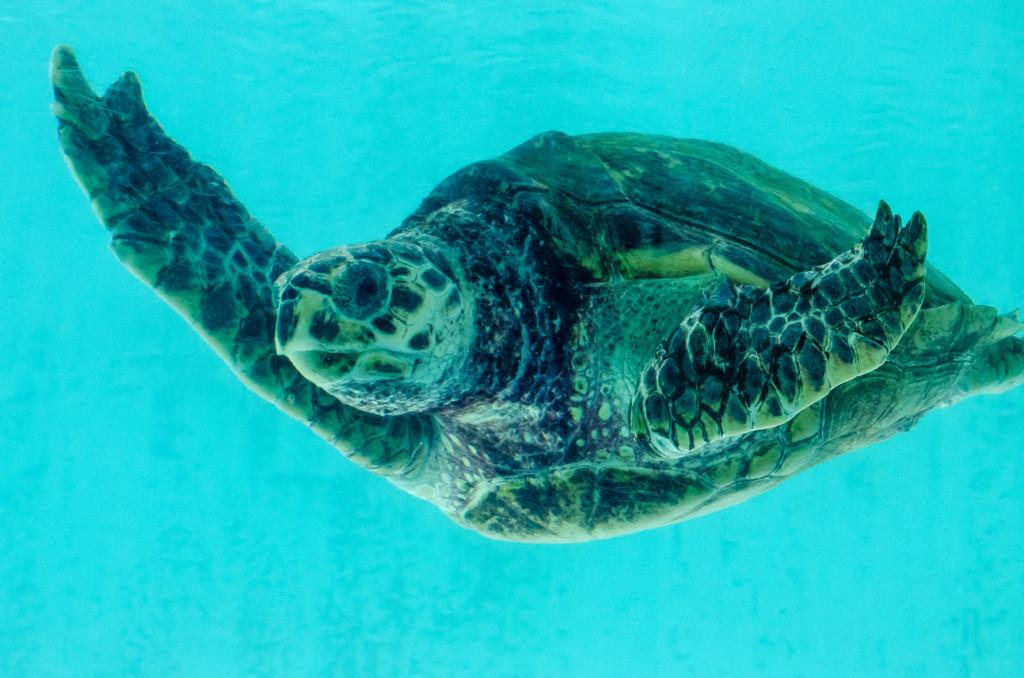What is the main subject of the image? There is a tortoise in the center of the image. Where is the tortoise located? The tortoise is in the water. What colors can be seen on the tortoise? The tortoise has green and black coloring. What color is the background of the image? The background of the image is blue. What type of whistle can be heard in the image? There is no whistle present in the image, as it features a tortoise in the water. How much profit can be made from the tortoise in the image? There is no indication of profit or any financial aspect related to the tortoise in the image. 